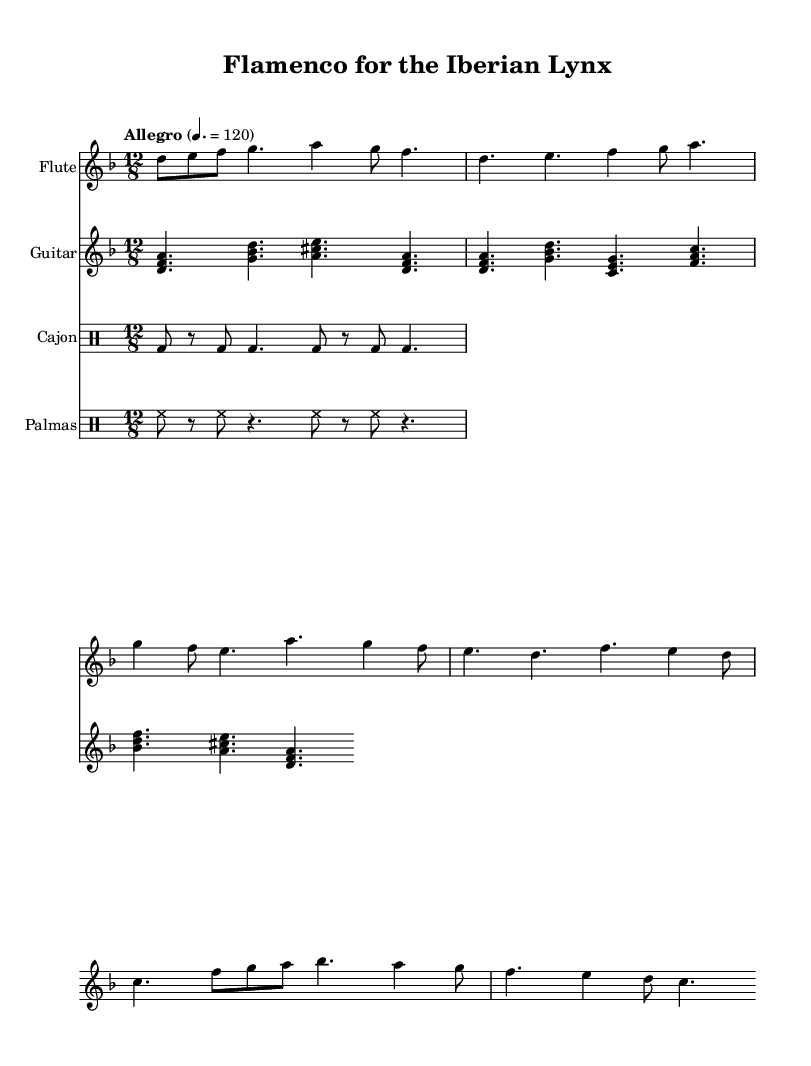What is the key signature of this music? The key signature is D minor, which has one flat (B flat).
Answer: D minor What is the time signature of this score? The time signature is 12/8, indicating a compound meter with four beats per measure and each beat divided into triplet eighth notes.
Answer: 12/8 What is the tempo marking for this piece? The tempo marking indicates 'Allegro', suggesting a fast and lively pace. The metronome marking specified is 120 beats per minute.
Answer: Allegro How many staves are used in this sheet music? There are four staves present, one each for the flute and guitar, and two for percussion instruments (cajon and palmas).
Answer: Four What instruments are featured in this composition? The instruments included are flute, guitar, cajon, and palmas, showcasing a typical flamenco ensemble.
Answer: Flute, guitar, cajon, palmas How does the rhythm pattern in the cajon differ from that in the palmas? The cajon rhythm consists of a repetitive bass drum beat pattern, while the palmas rhythm involves hand claps in a steady eighth note rhythm.
Answer: Different rhythmic patterns What is the structure of the piece regarding the guitar melody compared to the flute? The guitar presents chordal harmonies and accompaniment, while the flute features a melodic line with more single-note passages, providing contrast to the harmonic support.
Answer: Contrasting roles 